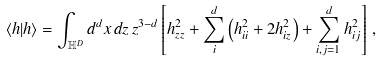Convert formula to latex. <formula><loc_0><loc_0><loc_500><loc_500>\langle h | h \rangle = \int _ { \mathbb { H } ^ { D } } d ^ { d } x \, d z \, z ^ { 3 - d } \left [ h _ { z z } ^ { 2 } + \sum _ { i } ^ { d } \left ( h ^ { 2 } _ { i i } + 2 h ^ { 2 } _ { i z } \right ) + \sum _ { i , j = 1 } ^ { d } h ^ { 2 } _ { i j } \right ] \, ,</formula> 